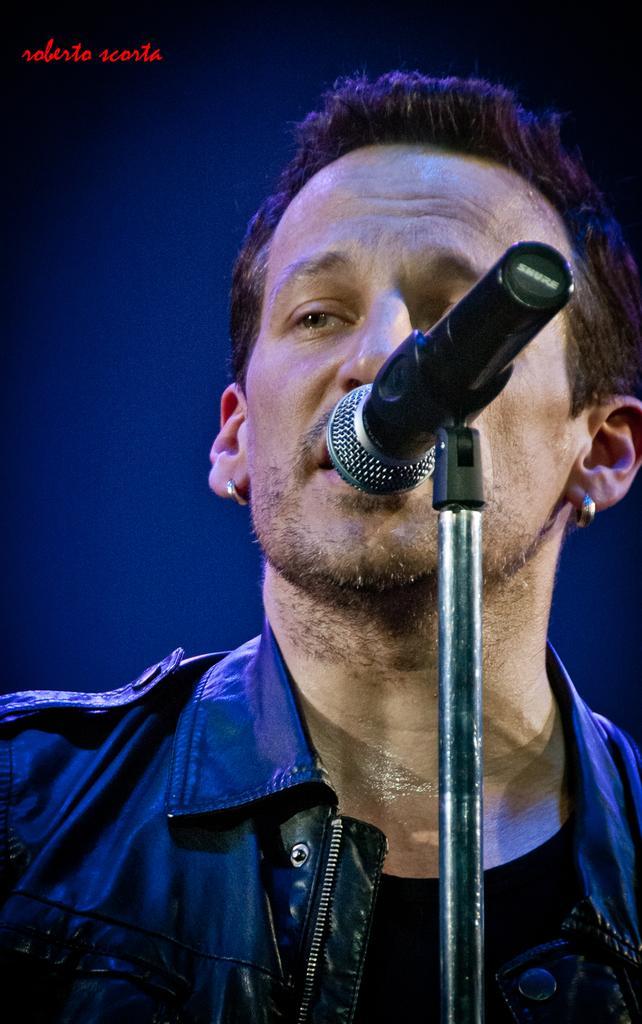How would you summarize this image in a sentence or two? In the image there is a man. He is wearing a black jacket,there is a mic in front of the man. 